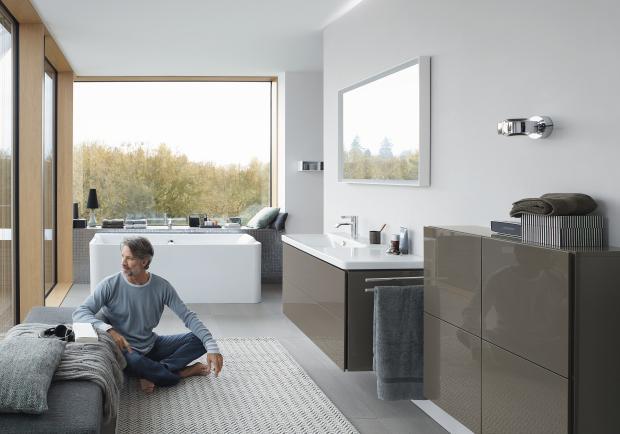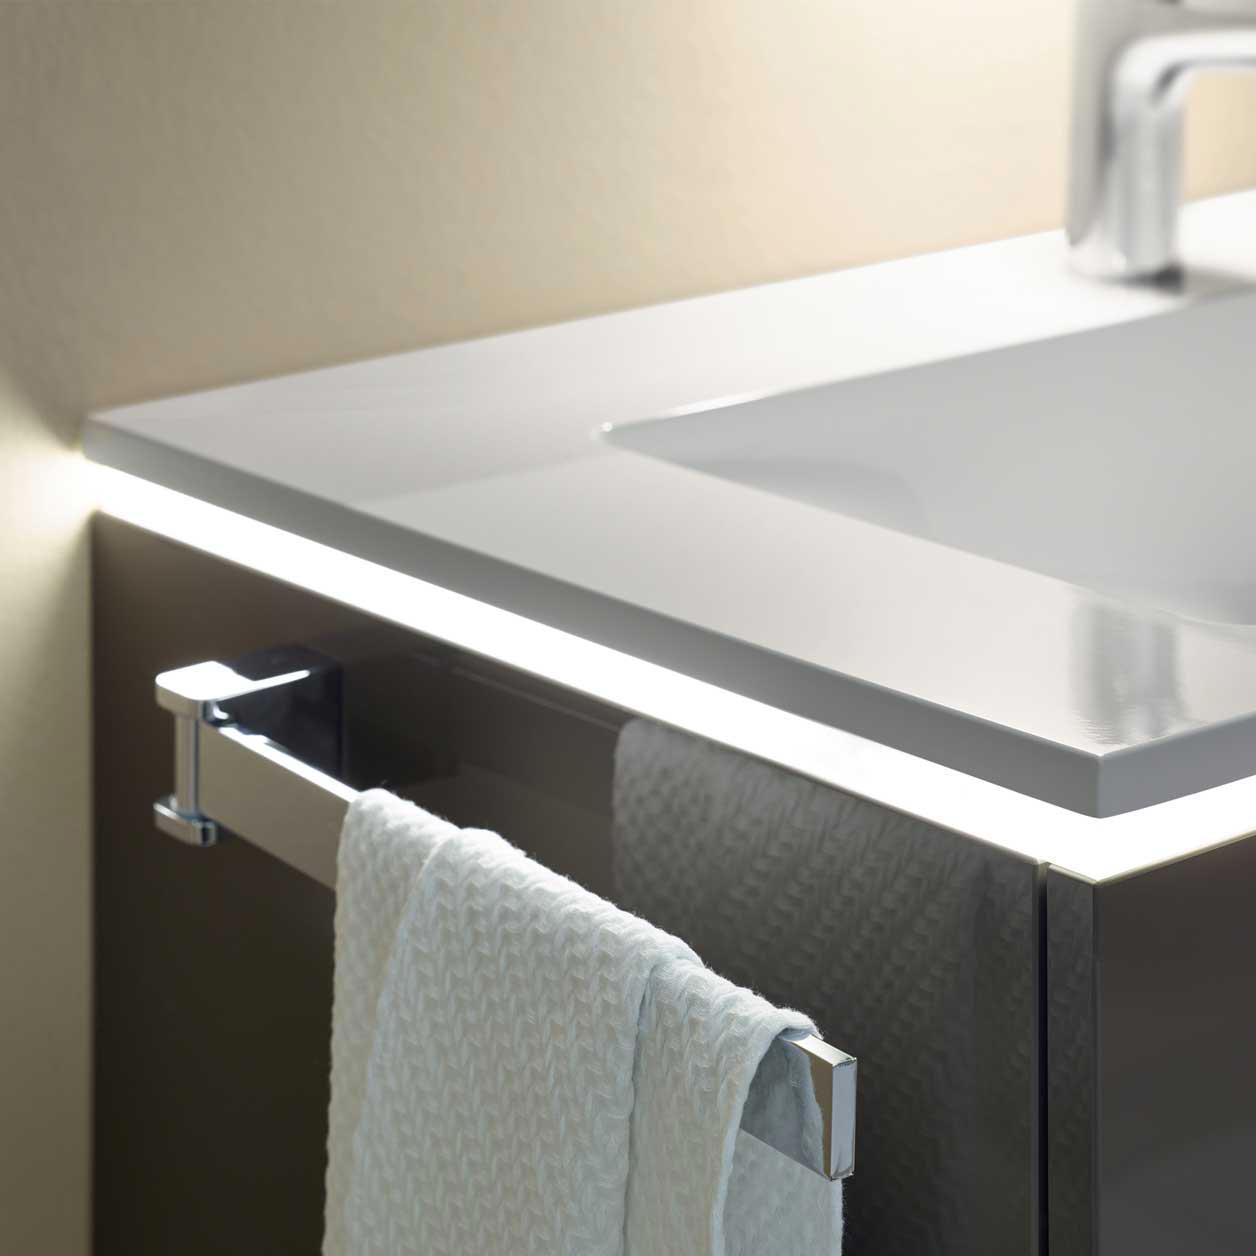The first image is the image on the left, the second image is the image on the right. For the images shown, is this caption "There are two open drawers visible." true? Answer yes or no. No. The first image is the image on the left, the second image is the image on the right. Evaluate the accuracy of this statement regarding the images: "The bathroom on the left features a freestanding bathtub and a wide rectangular mirror over the sink vanity, and the right image shows a towel on a chrome bar alongside the vanity.". Is it true? Answer yes or no. Yes. 